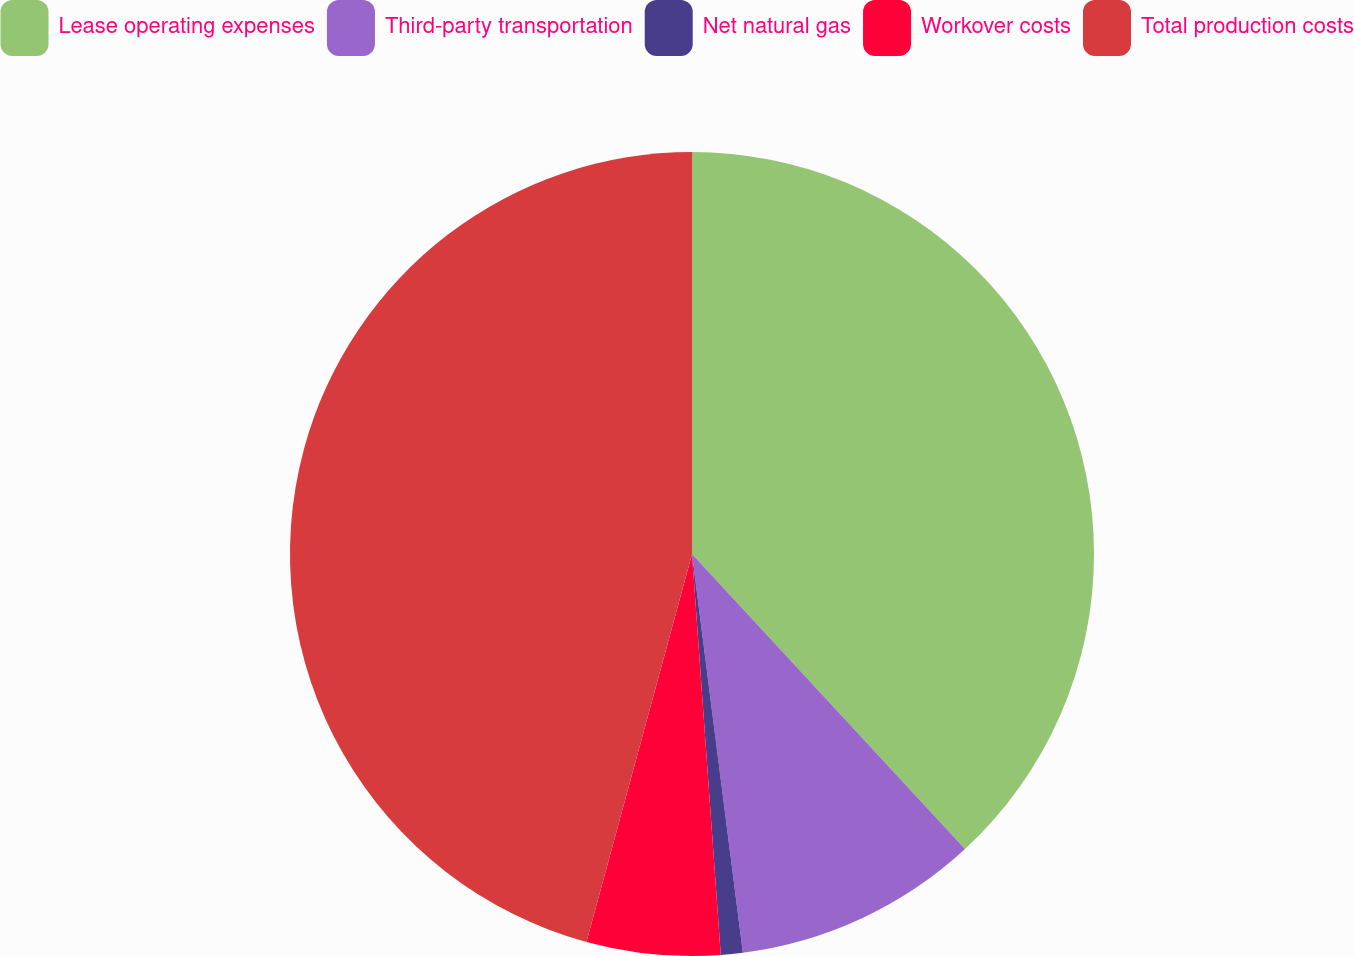Convert chart to OTSL. <chart><loc_0><loc_0><loc_500><loc_500><pie_chart><fcel>Lease operating expenses<fcel>Third-party transportation<fcel>Net natural gas<fcel>Workover costs<fcel>Total production costs<nl><fcel>38.12%<fcel>9.86%<fcel>0.88%<fcel>5.37%<fcel>45.77%<nl></chart> 